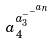Convert formula to latex. <formula><loc_0><loc_0><loc_500><loc_500>a _ { 4 } ^ { a _ { 3 } ^ { - ^ { - ^ { a _ { n } } } } }</formula> 